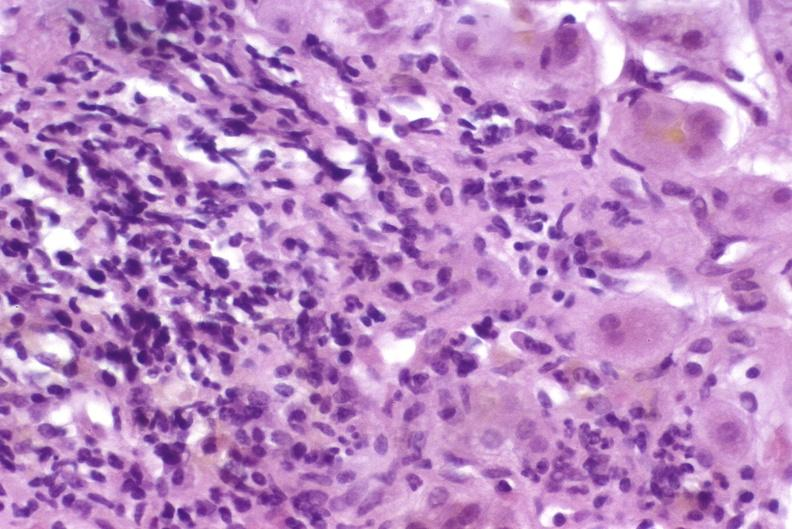s peritoneum present?
Answer the question using a single word or phrase. No 